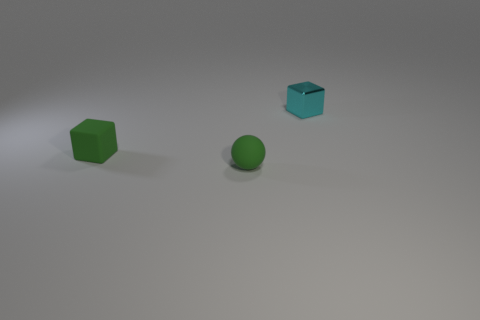Add 2 large brown rubber balls. How many objects exist? 5 Subtract 2 blocks. How many blocks are left? 0 Subtract 0 cyan cylinders. How many objects are left? 3 Subtract all cubes. How many objects are left? 1 Subtract all yellow blocks. Subtract all cyan cylinders. How many blocks are left? 2 Subtract all yellow cylinders. How many purple spheres are left? 0 Subtract all small objects. Subtract all tiny purple rubber cubes. How many objects are left? 0 Add 3 small matte cubes. How many small matte cubes are left? 4 Add 2 small things. How many small things exist? 5 